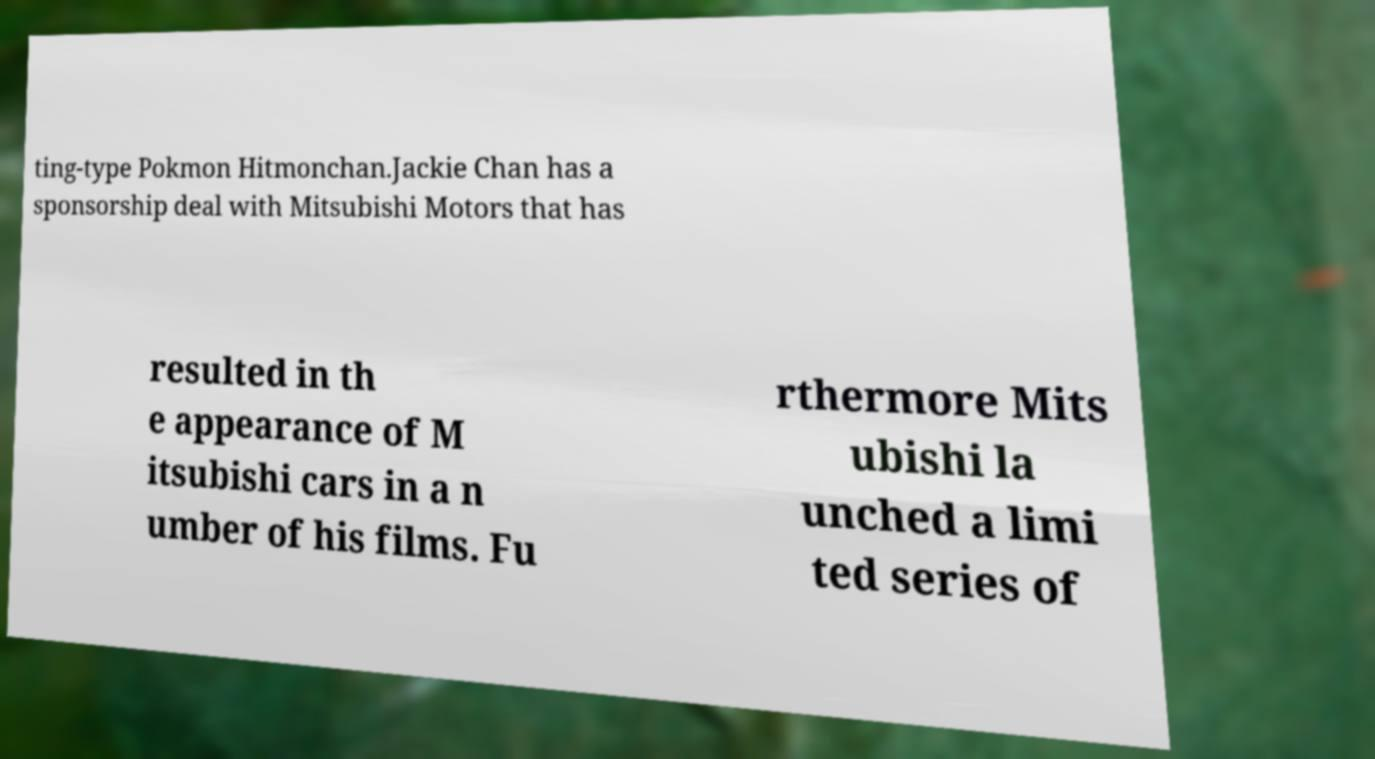What messages or text are displayed in this image? I need them in a readable, typed format. ting-type Pokmon Hitmonchan.Jackie Chan has a sponsorship deal with Mitsubishi Motors that has resulted in th e appearance of M itsubishi cars in a n umber of his films. Fu rthermore Mits ubishi la unched a limi ted series of 